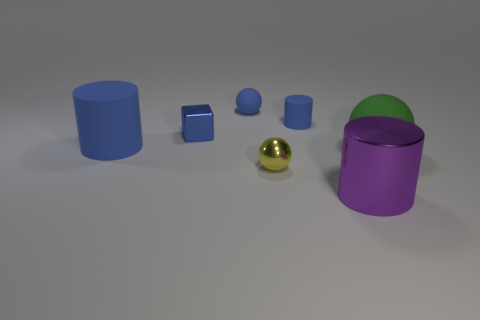How many other things are the same shape as the blue metal thing?
Offer a terse response. 0. Is the shape of the purple thing the same as the big blue thing?
Ensure brevity in your answer.  Yes. There is a rubber ball that is behind the blue cylinder that is behind the blue shiny object; what is its size?
Keep it short and to the point. Small. What is the color of the other metallic object that is the same shape as the large green thing?
Offer a terse response. Yellow. How many rubber balls are the same color as the small metallic cube?
Offer a very short reply. 1. The green rubber object has what size?
Your response must be concise. Large. Is the size of the metallic cylinder the same as the blue matte ball?
Your answer should be compact. No. There is a shiny object that is on the left side of the small cylinder and right of the small blue ball; what is its color?
Your answer should be compact. Yellow. What number of small blocks have the same material as the big purple cylinder?
Ensure brevity in your answer.  1. How many blocks are there?
Your response must be concise. 1. 